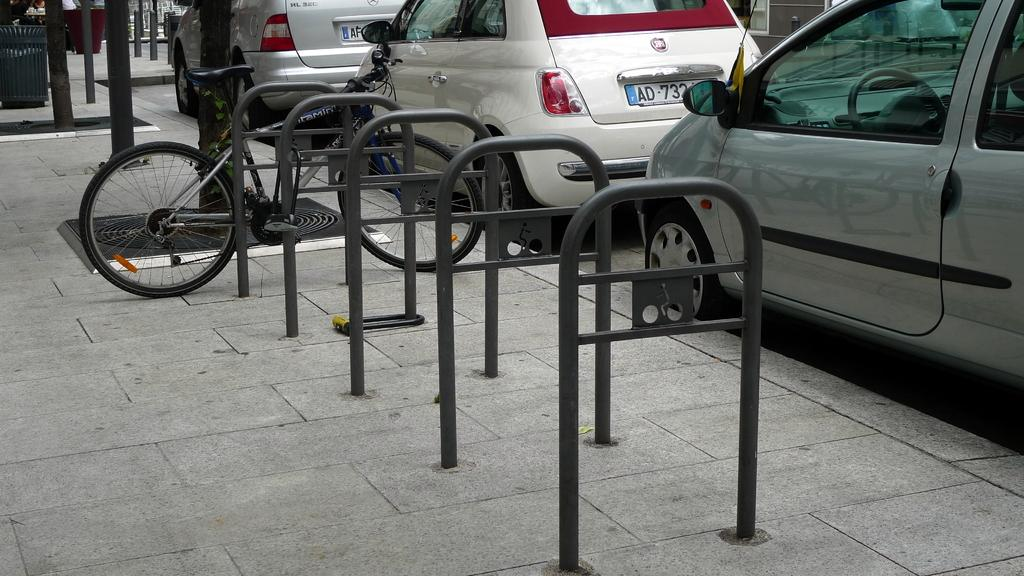What type of objects can be seen in the image? There are rods, a bicycle, a platform, vehicles, and poles in the image. Can you describe the platform in the image? The platform is a flat surface that supports the other objects in the image. What type of vehicles are present in the image? The vehicles in the image are not specified, but they are visible. What other unspecified objects can be seen in the image? There are other unspecified objects in the image, but their details are not provided. Can you tell me how many times the doctor sneezes in the image? There is no doctor or sneezing present in the image. What shape is the square in the image? There is no square present in the image. 